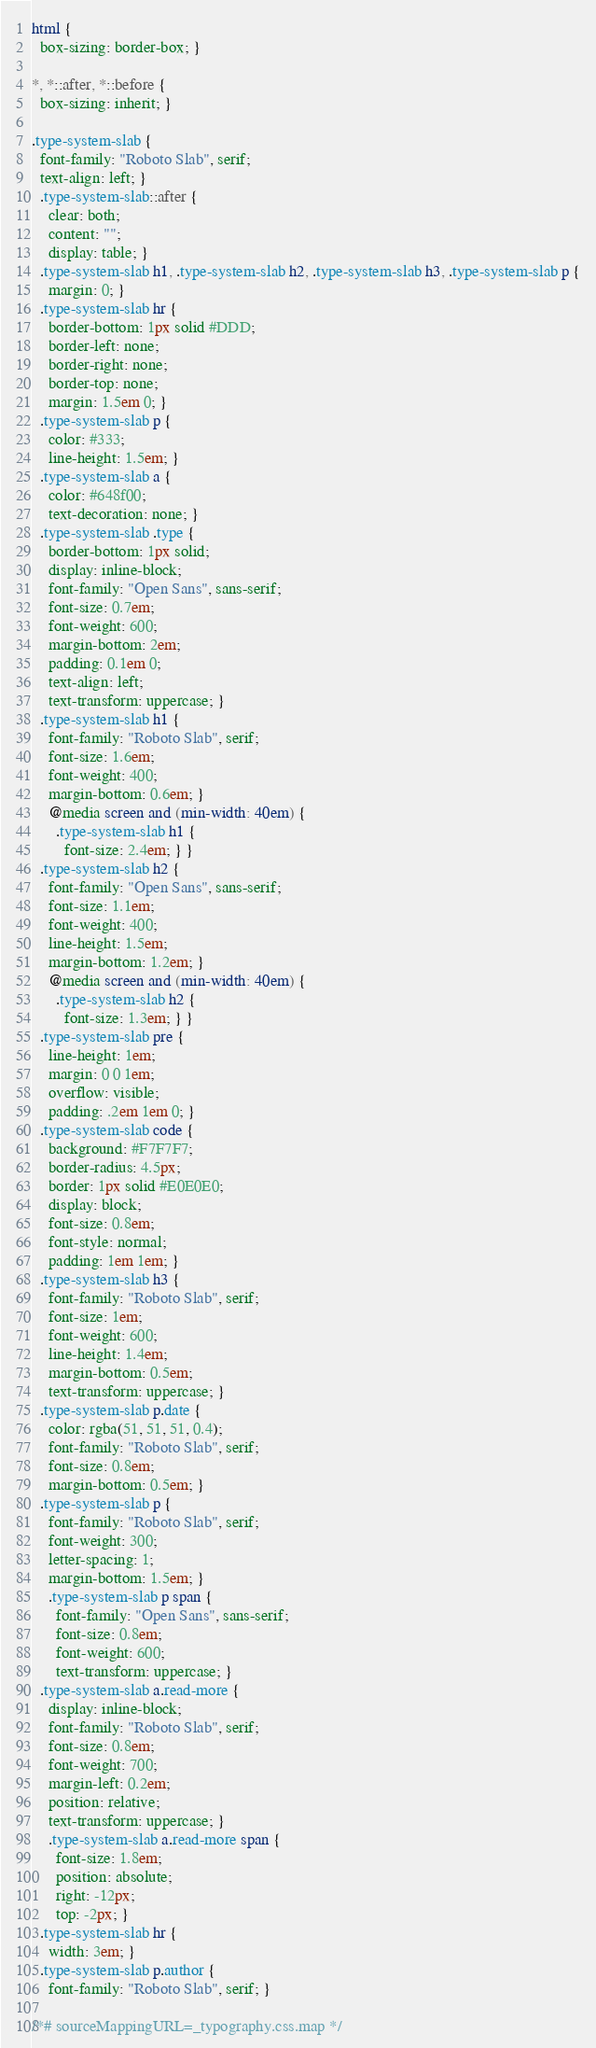Convert code to text. <code><loc_0><loc_0><loc_500><loc_500><_CSS_>html {
  box-sizing: border-box; }

*, *::after, *::before {
  box-sizing: inherit; }

.type-system-slab {
  font-family: "Roboto Slab", serif;
  text-align: left; }
  .type-system-slab::after {
    clear: both;
    content: "";
    display: table; }
  .type-system-slab h1, .type-system-slab h2, .type-system-slab h3, .type-system-slab p {
    margin: 0; }
  .type-system-slab hr {
    border-bottom: 1px solid #DDD;
    border-left: none;
    border-right: none;
    border-top: none;
    margin: 1.5em 0; }
  .type-system-slab p {
    color: #333;
    line-height: 1.5em; }
  .type-system-slab a {
    color: #648f00;
    text-decoration: none; }
  .type-system-slab .type {
    border-bottom: 1px solid;
    display: inline-block;
    font-family: "Open Sans", sans-serif;
    font-size: 0.7em;
    font-weight: 600;
    margin-bottom: 2em;
    padding: 0.1em 0;
    text-align: left;
    text-transform: uppercase; }
  .type-system-slab h1 {
    font-family: "Roboto Slab", serif;
    font-size: 1.6em;
    font-weight: 400;
    margin-bottom: 0.6em; }
    @media screen and (min-width: 40em) {
      .type-system-slab h1 {
        font-size: 2.4em; } }
  .type-system-slab h2 {
    font-family: "Open Sans", sans-serif;
    font-size: 1.1em;
    font-weight: 400;
    line-height: 1.5em;
    margin-bottom: 1.2em; }
    @media screen and (min-width: 40em) {
      .type-system-slab h2 {
        font-size: 1.3em; } }
  .type-system-slab pre {
    line-height: 1em;
    margin: 0 0 1em;
    overflow: visible;
    padding: .2em 1em 0; }
  .type-system-slab code {
    background: #F7F7F7;
    border-radius: 4.5px;
    border: 1px solid #E0E0E0;
    display: block;
    font-size: 0.8em;
    font-style: normal;
    padding: 1em 1em; }
  .type-system-slab h3 {
    font-family: "Roboto Slab", serif;
    font-size: 1em;
    font-weight: 600;
    line-height: 1.4em;
    margin-bottom: 0.5em;
    text-transform: uppercase; }
  .type-system-slab p.date {
    color: rgba(51, 51, 51, 0.4);
    font-family: "Roboto Slab", serif;
    font-size: 0.8em;
    margin-bottom: 0.5em; }
  .type-system-slab p {
    font-family: "Roboto Slab", serif;
    font-weight: 300;
    letter-spacing: 1;
    margin-bottom: 1.5em; }
    .type-system-slab p span {
      font-family: "Open Sans", sans-serif;
      font-size: 0.8em;
      font-weight: 600;
      text-transform: uppercase; }
  .type-system-slab a.read-more {
    display: inline-block;
    font-family: "Roboto Slab", serif;
    font-size: 0.8em;
    font-weight: 700;
    margin-left: 0.2em;
    position: relative;
    text-transform: uppercase; }
    .type-system-slab a.read-more span {
      font-size: 1.8em;
      position: absolute;
      right: -12px;
      top: -2px; }
  .type-system-slab hr {
    width: 3em; }
  .type-system-slab p.author {
    font-family: "Roboto Slab", serif; }

/*# sourceMappingURL=_typography.css.map */
</code> 